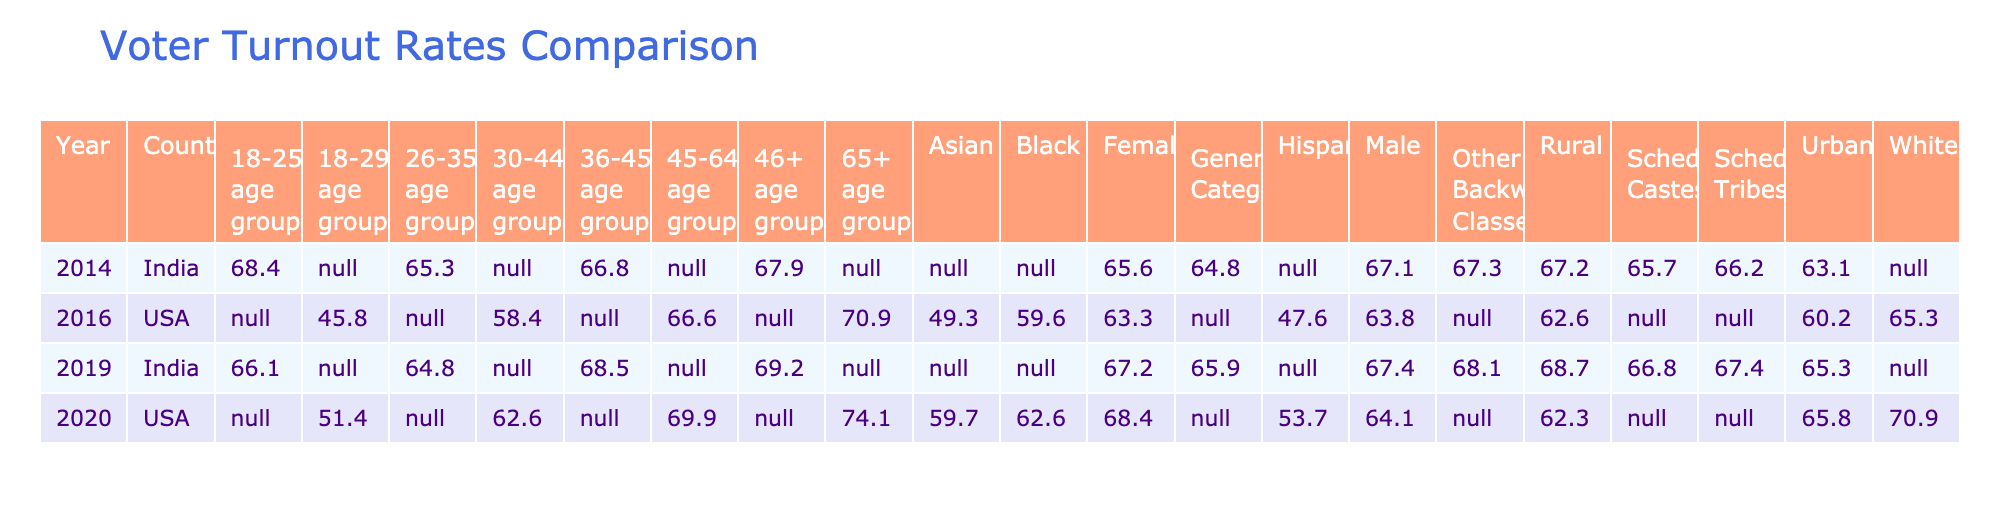What was the voter turnout rate for females in India in 2019? The table shows the demographic "Female" under the year 2019 for India, which has a turnout rate of 67.2.
Answer: 67.2 Which demographic group had the highest voter turnout rate in the USA in 2020? The turnout rates for each demographic group in the USA in 2020 are provided. The "65+ age group" has the highest turnout rate of 74.1.
Answer: 74.1 What is the difference in voter turnout rates between urban and rural populations in India in 2019? In 2019, the urban turnout rate is 65.3 and the rural rate is 68.7. Calculating the difference: 68.7 - 65.3 = 3.4.
Answer: 3.4 Did the voter turnout rate for the 18-25 age group increase or decrease from 2014 to 2019 in India? In 2014, the turnout for the 18-25 age group was 68.4, and in 2019 it was 66.1. Since 66.1 is less than 68.4, it decreased.
Answer: Decrease What is the average voter turnout rate for males across the provided years in India? The turnout rates for males in India are 67.4 (2019), 67.1 (2014), and we have no data for the USA. So the average is (67.4 + 67.1) / 2 = 67.25.
Answer: 67.25 Which age group had the lowest voter turnout in the USA in 2020? The table shows the turnout rates for each age group in the USA in 2020. The "18-29 age group" has the lowest turnout rate of 51.4.
Answer: 51.4 Is the voter turnout rate for scheduled tribes in India in 2014 higher than the turnout rate for the Black demographic in the USA in 2020? The turnout rate for scheduled tribes in India in 2014 is 66.2, while for Blacks in the USA in 2020, it is 62.6. Since 66.2 is greater than 62.6, the statement is true.
Answer: Yes What was the change in voter turnout rate for females in the USA from 2016 to 2020? The turnout rate for females in 2016 is 63.3, and in 2020 it is 68.4. The change is 68.4 - 63.3 = 5.1.
Answer: 5.1 Which demographic group in India had the lowest turnout rate in 2014? In the 2014 data, if we look at all the demographics, the "General Category" had the lowest voter turnout rate of 64.8.
Answer: 64.8 